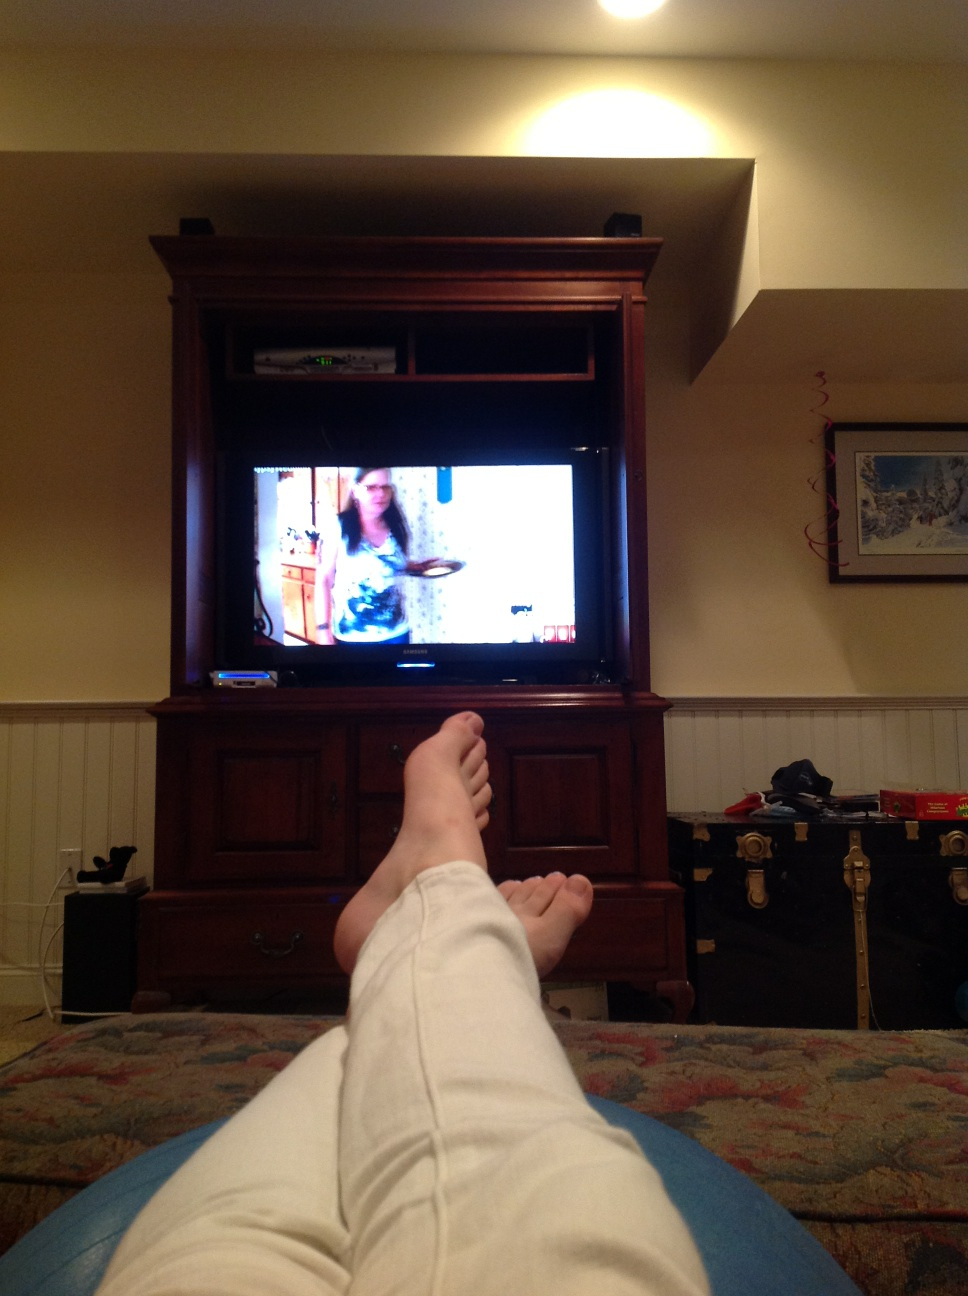What kind of furniture is seen in front of the television? In front of the television, there appears to be a wooden coffee table with decorative items and remote controls on top. 